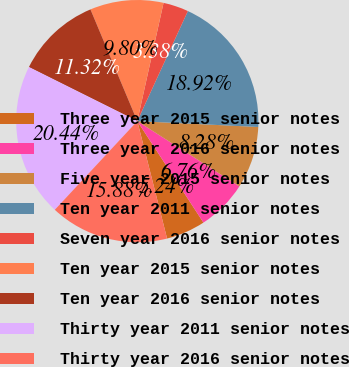Convert chart to OTSL. <chart><loc_0><loc_0><loc_500><loc_500><pie_chart><fcel>Three year 2015 senior notes<fcel>Three year 2016 senior notes<fcel>Five year 2015 senior notes<fcel>Ten year 2011 senior notes<fcel>Seven year 2016 senior notes<fcel>Ten year 2015 senior notes<fcel>Ten year 2016 senior notes<fcel>Thirty year 2011 senior notes<fcel>Thirty year 2016 senior notes<nl><fcel>5.24%<fcel>6.76%<fcel>8.28%<fcel>18.92%<fcel>3.38%<fcel>9.8%<fcel>11.32%<fcel>20.44%<fcel>15.88%<nl></chart> 